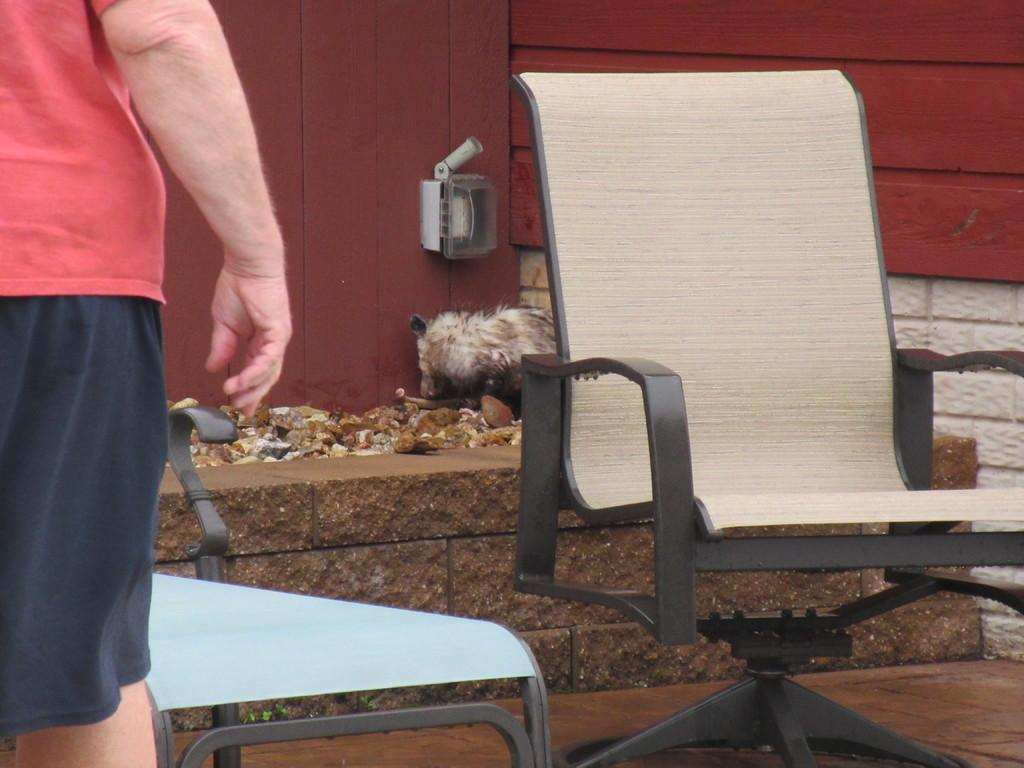What is the position of the person in the image? There is a person standing on the left side of the image. What object can be seen on the right side of the image? There is a chair on the right side of the image. What can be seen in the background of the image? There is a wall visible in the background of the image. What type of tax is being discussed in the image? There is no discussion of tax in the image; it features a person standing next to a chair with a wall in the background. What kind of grain is visible on the chair in the image? There is no grain present in the image; it only shows a person and a chair with a wall in the background. 